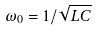Convert formula to latex. <formula><loc_0><loc_0><loc_500><loc_500>\omega _ { 0 } = 1 / \sqrt { L C }</formula> 